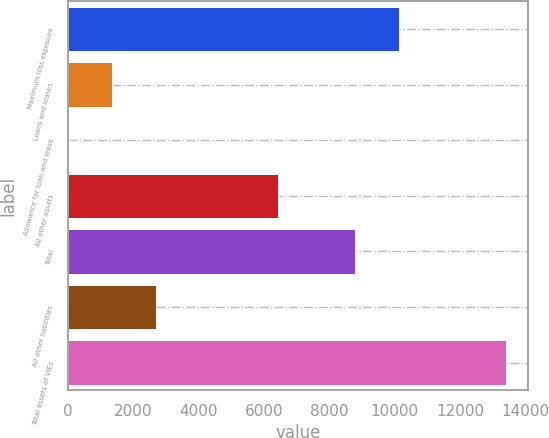Convert chart. <chart><loc_0><loc_0><loc_500><loc_500><bar_chart><fcel>Maximum loss exposure<fcel>Loans and leases<fcel>Allowance for loan and lease<fcel>All other assets<fcel>Total<fcel>All other liabilities<fcel>Total assets of VIEs<nl><fcel>10129.4<fcel>1361.4<fcel>22<fcel>6440<fcel>8790<fcel>2700.8<fcel>13416<nl></chart> 